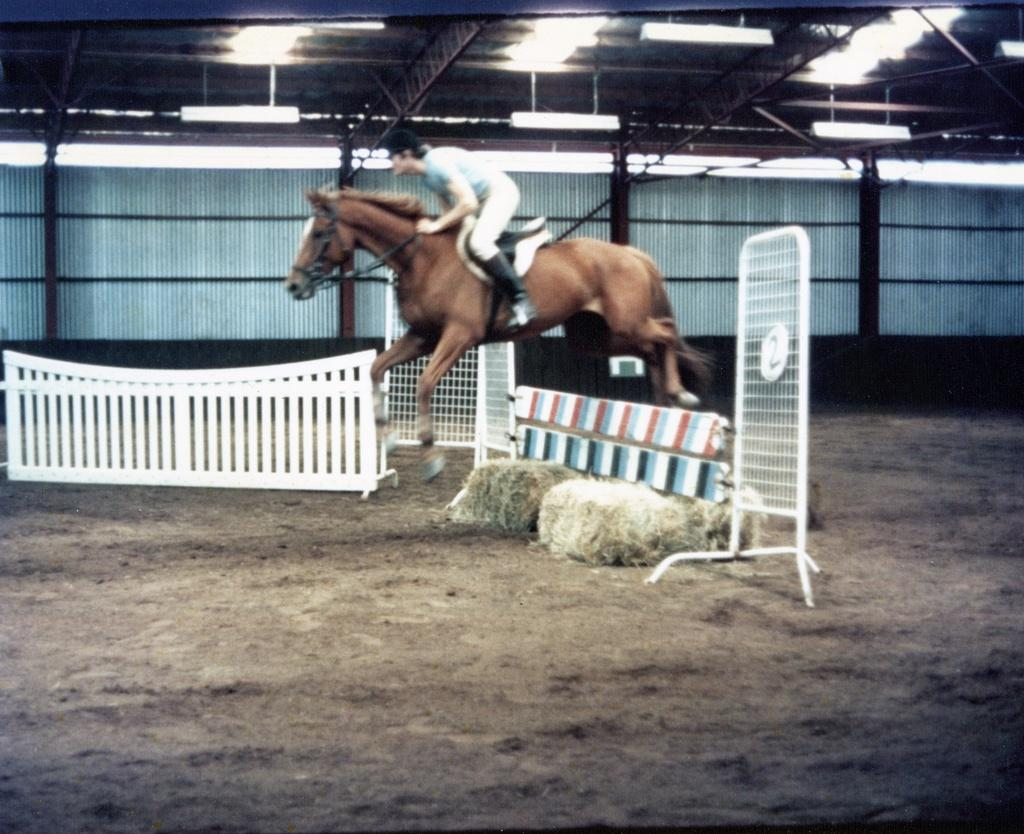What animal is the main subject of the image? There is a horse in the image. What is the horse doing in the image? The horse is jumping in the image. Is there a person involved in the image? Yes, there is a person sitting on the horse. What can be seen in the background of the image? There is a shed, grills, electric lights, and lawn straw on the ground in the background of the image. What type of rifle is the person using to burn the lawn straw in the image? There is no rifle or burning activity present in the image. What type of education is being provided to the horse in the image? There is no indication of any educational activity involving the horse in the image. 